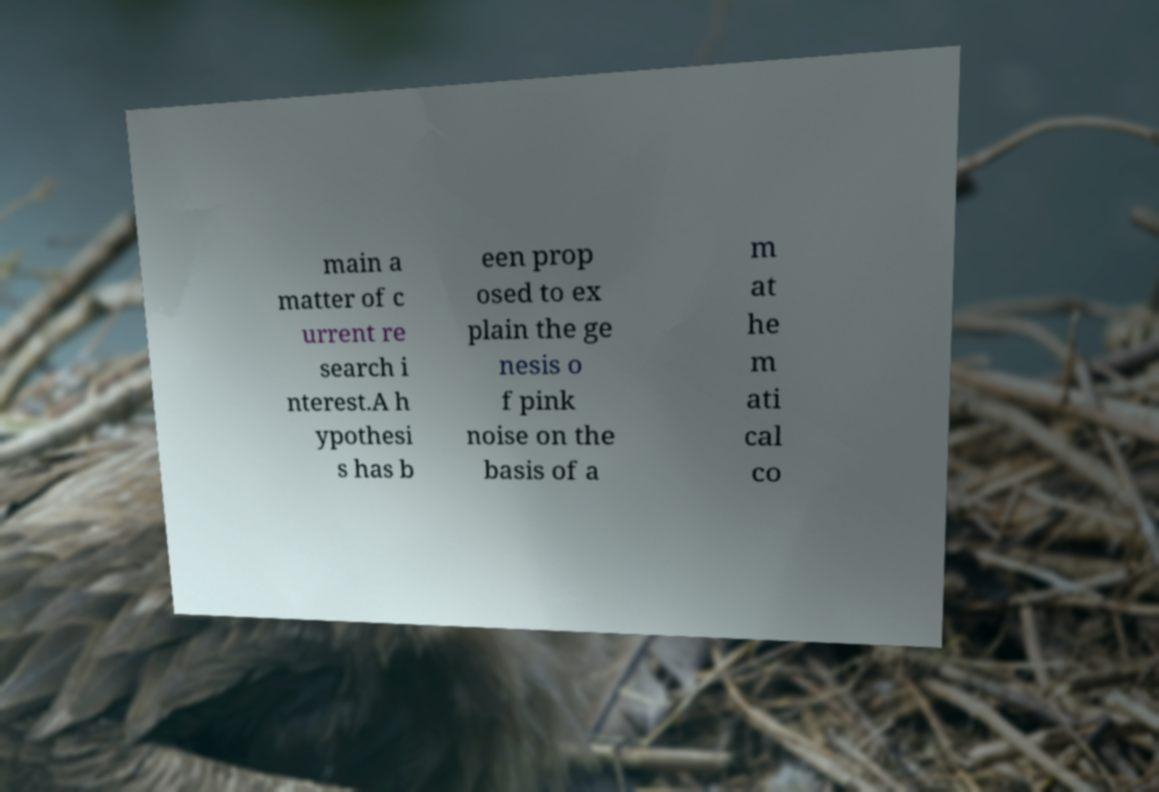Can you accurately transcribe the text from the provided image for me? The text in the image is somewhat obscured and fragmented, but it appears to read: 'main a matter of current research interest. A hypothesis has been proposed to explain the genesis of pink noise on the basis of a mathematical co'. The transcription might be slightly imprecise due to the blurred portions of the text. 